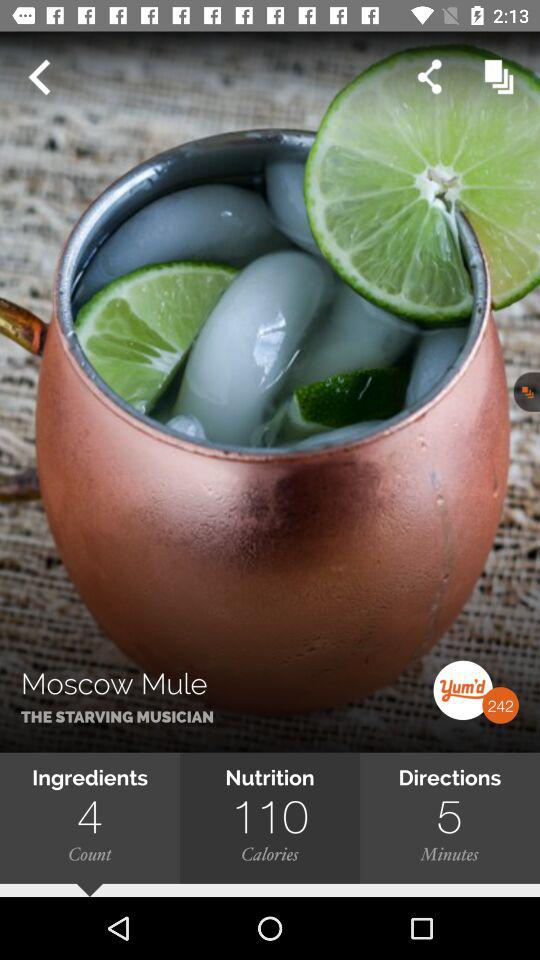What's the number mentioned with "yum'd"? The number mentioned with "yum'd" is 242. 